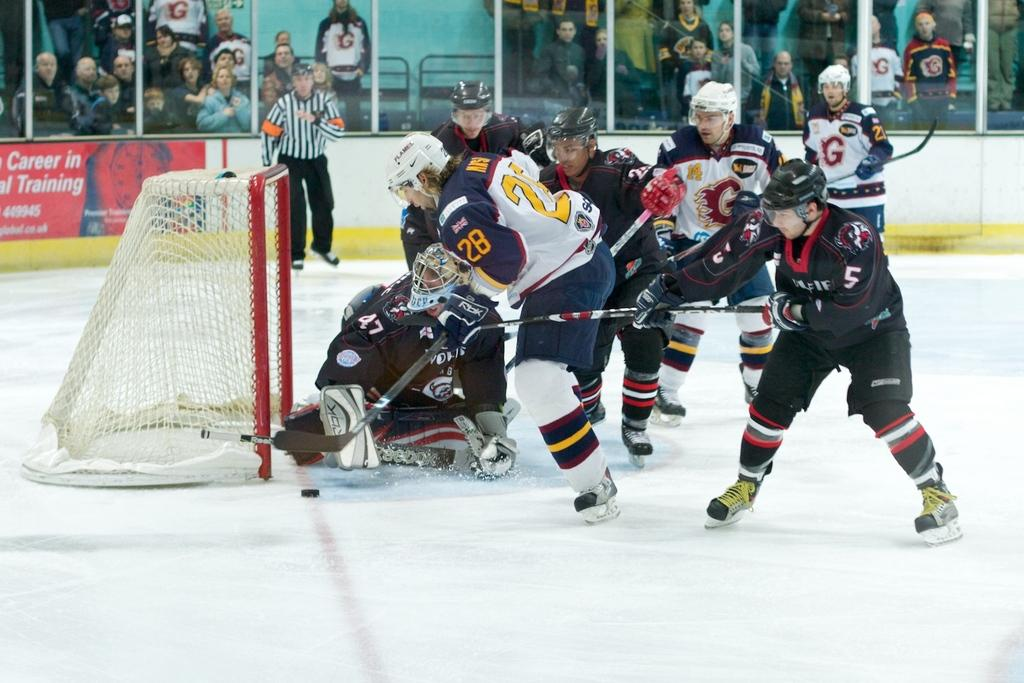<image>
Describe the image concisely. Player number 28 looks to score for his hockey team. 